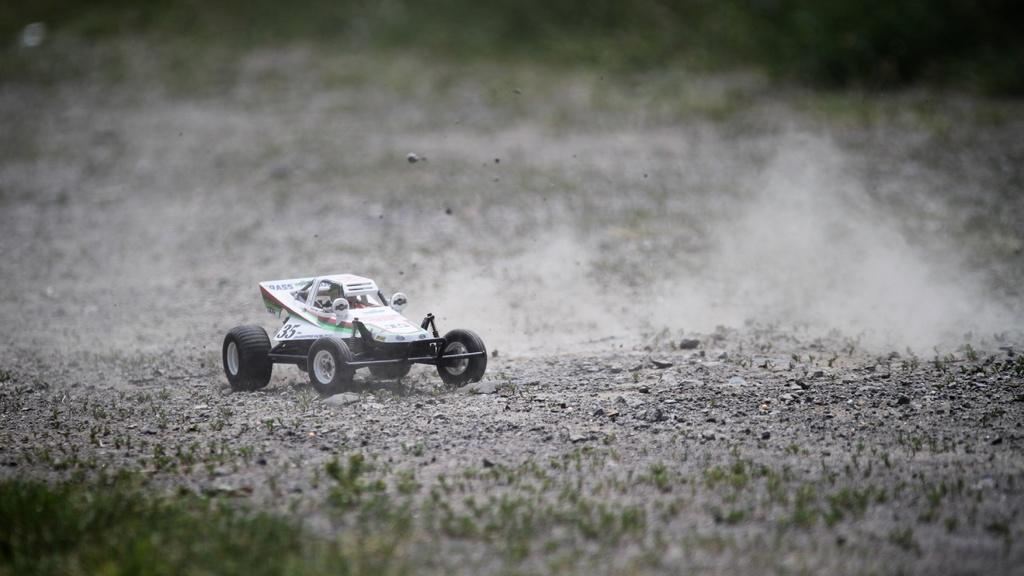What type of toy is in the image? There is a toy vehicle in the image. Where is the toy vehicle located? The toy vehicle is on the land. What type of vegetation can be seen at the bottom of the image? Grass is visible at the bottom of the image. How many frogs are jumping around the toy vehicle in the image? There are no frogs present in the image; it only features a toy vehicle on the land. 